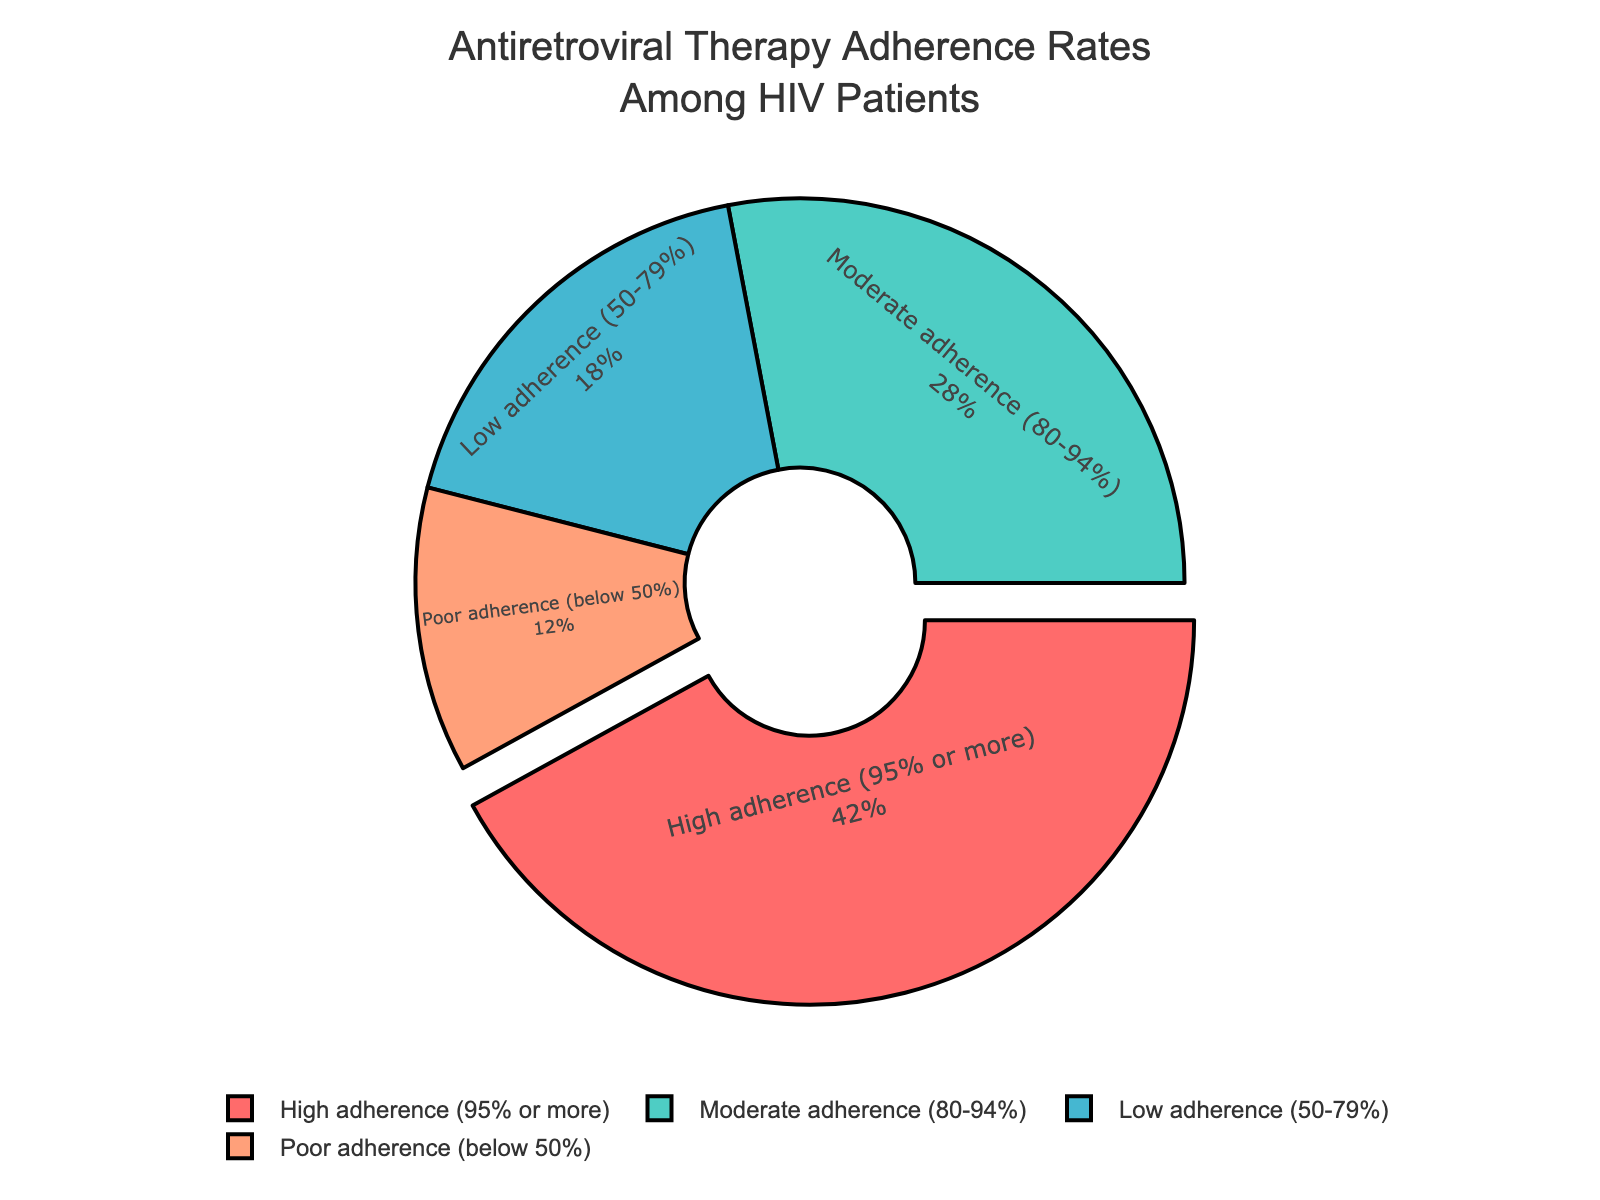What is the highest adherence rate category? The pie chart shows that "High adherence (95% or more)" has the largest section of the pie.
Answer: High adherence (95% or more) Which adherence rate category is the smallest? The pie chart shows that "Poor adherence (below 50%)" has the smallest section of the pie.
Answer: Poor adherence (below 50%) How much larger is the percentage of high adherence compared to low adherence? The percentage of high adherence is 42% and the percentage of low adherence is 18%. The difference is 42% - 18% = 24%.
Answer: 24% What is the combined percentage of moderate and low adherence rates? The percentage of moderate adherence is 28% and low adherence is 18%, adding them together: 28% + 18% = 46%.
Answer: 46% Which colors represent the high adherence and poor adherence categories? The high adherence section is pulled out slightly and is colored red, while the poor adherence section is colored salmon.
Answer: High adherence is red, poor adherence is salmon Is the percentage of patients with moderate adherence greater or less than the percentage of patients with low adherence? The pie chart shows that the moderate adherence percentage (28%) is greater than the low adherence percentage (18%).
Answer: Greater What is the percentage difference between patients with high adherence and those with moderate adherence? The high adherence is 42%, and the moderate adherence is 28%. The difference is 42% - 28% = 14%.
Answer: 14% Do the combined percentages of moderate and low adherence exceed the percentage of high adherence? The combined percentage of moderate (28%) and low adherence (18%) is 46%, which is greater than the high adherence percentage of 42%.
Answer: Yes Which adherence segment is visually standing out and how? The high adherence segment is visually standing out by being slightly pulled out from the rest of the pie chart sections.
Answer: High adherence is pulled out By how much does the combined percentage of low and poor adherence fall short of 50%? The combined percentages of low (18%) and poor adherence (12%) is 18% + 12% = 30%. It falls short of 50% by 50% - 30% = 20%.
Answer: 20% 